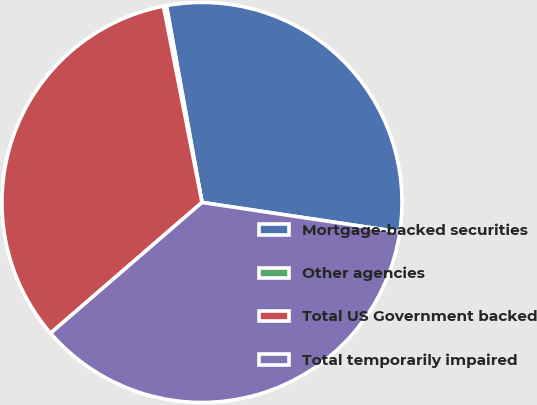Convert chart to OTSL. <chart><loc_0><loc_0><loc_500><loc_500><pie_chart><fcel>Mortgage-backed securities<fcel>Other agencies<fcel>Total US Government backed<fcel>Total temporarily impaired<nl><fcel>30.2%<fcel>0.24%<fcel>33.25%<fcel>36.3%<nl></chart> 